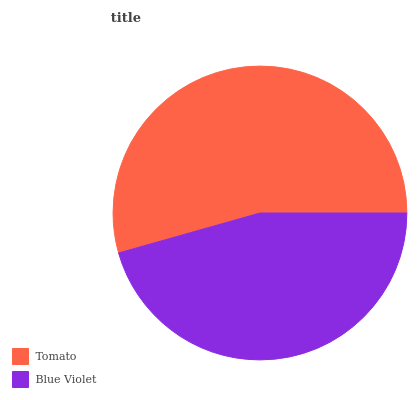Is Blue Violet the minimum?
Answer yes or no. Yes. Is Tomato the maximum?
Answer yes or no. Yes. Is Blue Violet the maximum?
Answer yes or no. No. Is Tomato greater than Blue Violet?
Answer yes or no. Yes. Is Blue Violet less than Tomato?
Answer yes or no. Yes. Is Blue Violet greater than Tomato?
Answer yes or no. No. Is Tomato less than Blue Violet?
Answer yes or no. No. Is Tomato the high median?
Answer yes or no. Yes. Is Blue Violet the low median?
Answer yes or no. Yes. Is Blue Violet the high median?
Answer yes or no. No. Is Tomato the low median?
Answer yes or no. No. 